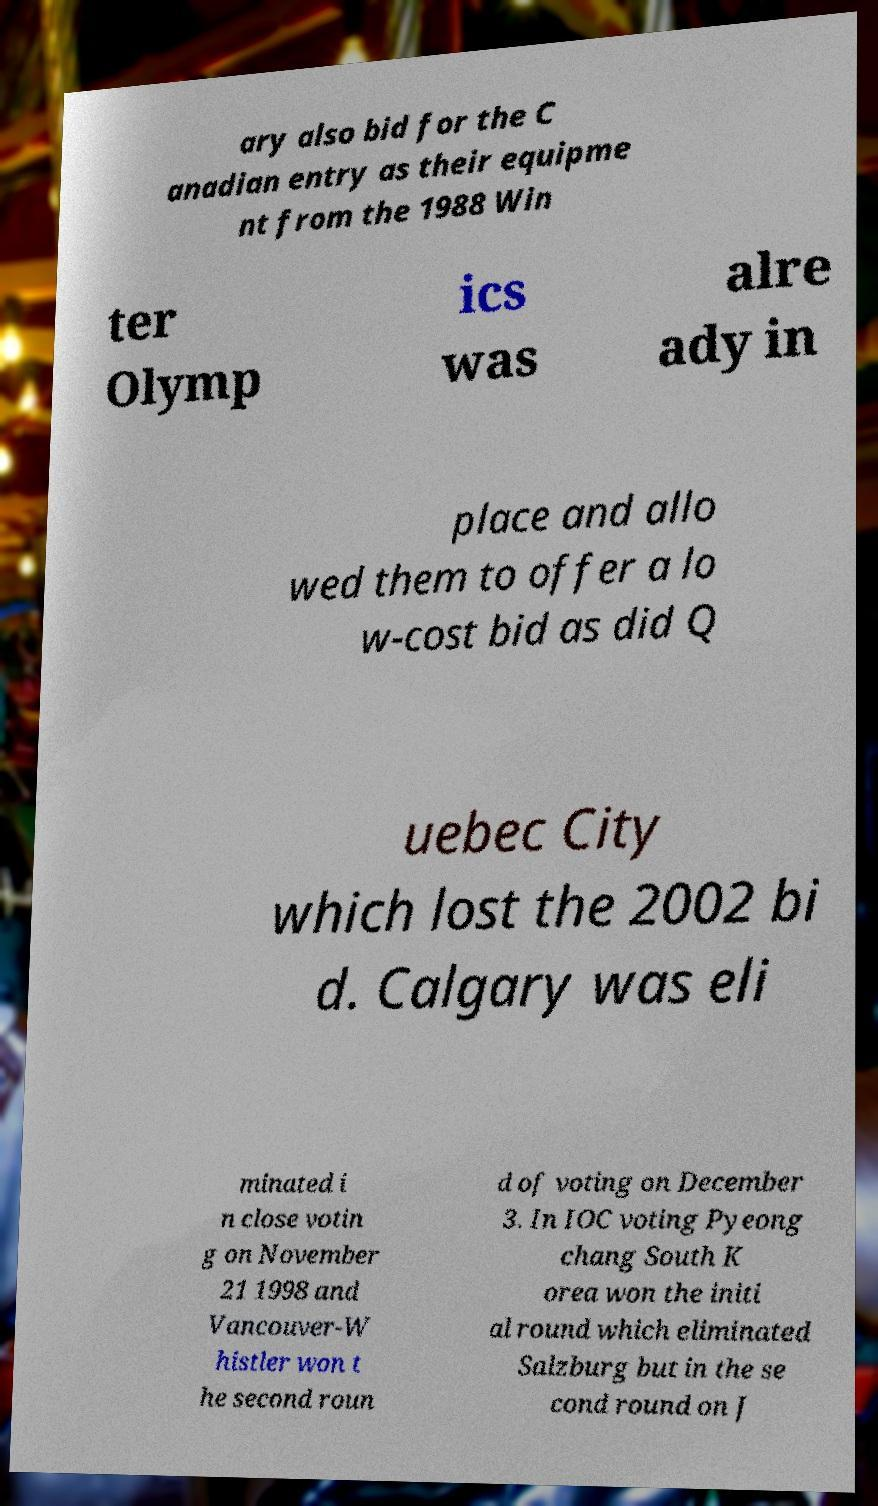For documentation purposes, I need the text within this image transcribed. Could you provide that? ary also bid for the C anadian entry as their equipme nt from the 1988 Win ter Olymp ics was alre ady in place and allo wed them to offer a lo w-cost bid as did Q uebec City which lost the 2002 bi d. Calgary was eli minated i n close votin g on November 21 1998 and Vancouver-W histler won t he second roun d of voting on December 3. In IOC voting Pyeong chang South K orea won the initi al round which eliminated Salzburg but in the se cond round on J 